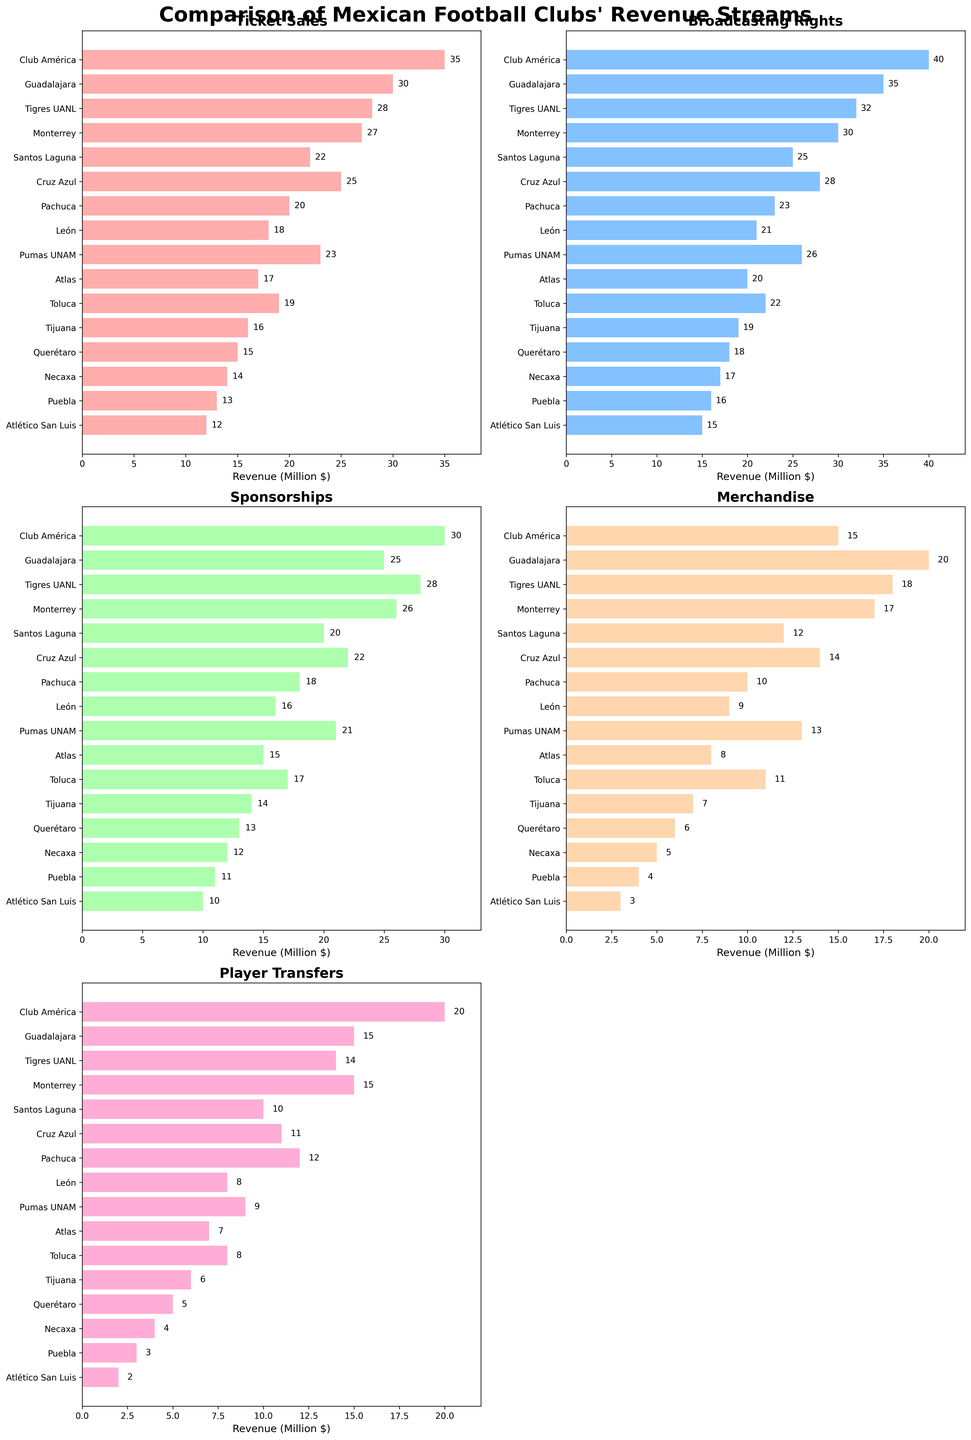Which club has the highest revenue from Ticket Sales? By looking at the height of bars in the Ticket Sales subplot, Club América has the longest bar indicating it has the highest revenue from Ticket Sales.
Answer: Club América Which clubs have lower revenue from Sponsorships than Guadalajara? In the Sponsorships subplot, the bars for all clubs are present. By comparing Guadalajara's bar with others, Atlas, Querétaro, Necaxa, Puebla, and Atlético San Luis have shorter bars, indicating they have lower revenue from Sponsorships.
Answer: Atlas, Querétaro, Necaxa, Puebla, Atlético San Luis How does León's revenue from Broadcasting Rights compare to that of Santos Laguna? In the Broadcasting Rights subplot, León's bar is shorter than that of Santos Laguna, indicating León has lesser revenue from Broadcasting Rights compared to Santos Laguna.
Answer: León's revenue is less than Santos Laguna's What is the sum of revenues from Player Transfers for Club América and Tigres UANL? In the Player Transfers subplot, Club América has 20 million $ and Tigres UANL has 14 million $. Adding these values gives 20 + 14 = 34 million $.
Answer: 34 million $ Which club shows the most balance across all revenue sources, without any extremely dominating category? By visually comparing all subplots and looking at the bars of each club, Monterrey has relatively balanced heights across all categories without a single revenue source significantly dominating.
Answer: Monterrey What is the combined revenue from Ticket Sales and Merchandise for any club that ranks between 4th to 6th position? Choose a club that ranks 4th to 6th in Ticket Sales subplot. For Monterrey: Ticket Sales = 27 million $, Merchandise = 17 million $. Sum = 27 + 17 = 44 million $.
Answer: 44 million $ Which revenue stream is the least significant for most clubs, and how can you tell? By examining the general height of the bars across all subplots, the Player Transfers subplot generally has the shortest bars, indicating it is the least significant revenue stream for most clubs.
Answer: Player Transfers What is the average revenue from Merchandise for all clubs? Adding the Merchandise revenues: 15 + 20 + 18 + 17 + 12 + 14 + 10 + 9 + 13 + 8 + 11 + 7 + 6 + 5 + 4 + 3 = 172 million $. There are 16 clubs, so the average is 172 / 16 = 10.75 million $.
Answer: 10.75 million $ How does the revenue from Broadcasting Rights for Pumas UNAM compare to that of Tijuana? In the Broadcasting Rights subplot, Pumas UNAM has a higher bar than Tijuana, indicating higher revenue for Pumas UNAM in Broadcasting Rights.
Answer: Pumas UNAM has higher revenue than Tijuana 